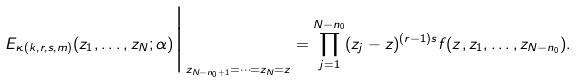Convert formula to latex. <formula><loc_0><loc_0><loc_500><loc_500>E _ { \kappa ( k , r , s , m ) } ( z _ { 1 } , \dots , z _ { N } ; \alpha ) \Big | _ { z _ { N - n _ { 0 } + 1 } = \dots = z _ { N } = z } = \prod _ { j = 1 } ^ { N - n _ { 0 } } ( z _ { j } - z ) ^ { ( r - 1 ) s } f ( z , z _ { 1 } , \dots , z _ { N - n _ { 0 } } ) .</formula> 